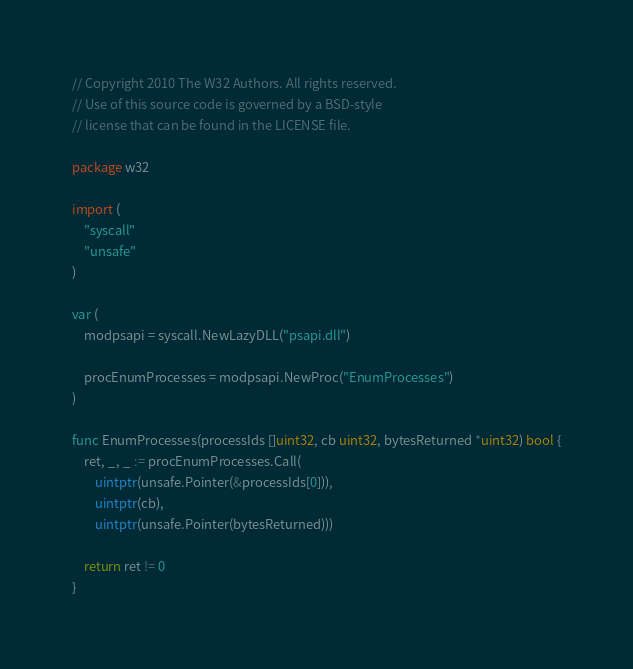<code> <loc_0><loc_0><loc_500><loc_500><_Go_>// Copyright 2010 The W32 Authors. All rights reserved.
// Use of this source code is governed by a BSD-style
// license that can be found in the LICENSE file.

package w32

import (
    "syscall"
    "unsafe"
)

var (
    modpsapi = syscall.NewLazyDLL("psapi.dll")

    procEnumProcesses = modpsapi.NewProc("EnumProcesses")
)

func EnumProcesses(processIds []uint32, cb uint32, bytesReturned *uint32) bool {
    ret, _, _ := procEnumProcesses.Call(
        uintptr(unsafe.Pointer(&processIds[0])),
        uintptr(cb),
        uintptr(unsafe.Pointer(bytesReturned)))

    return ret != 0
}
</code> 